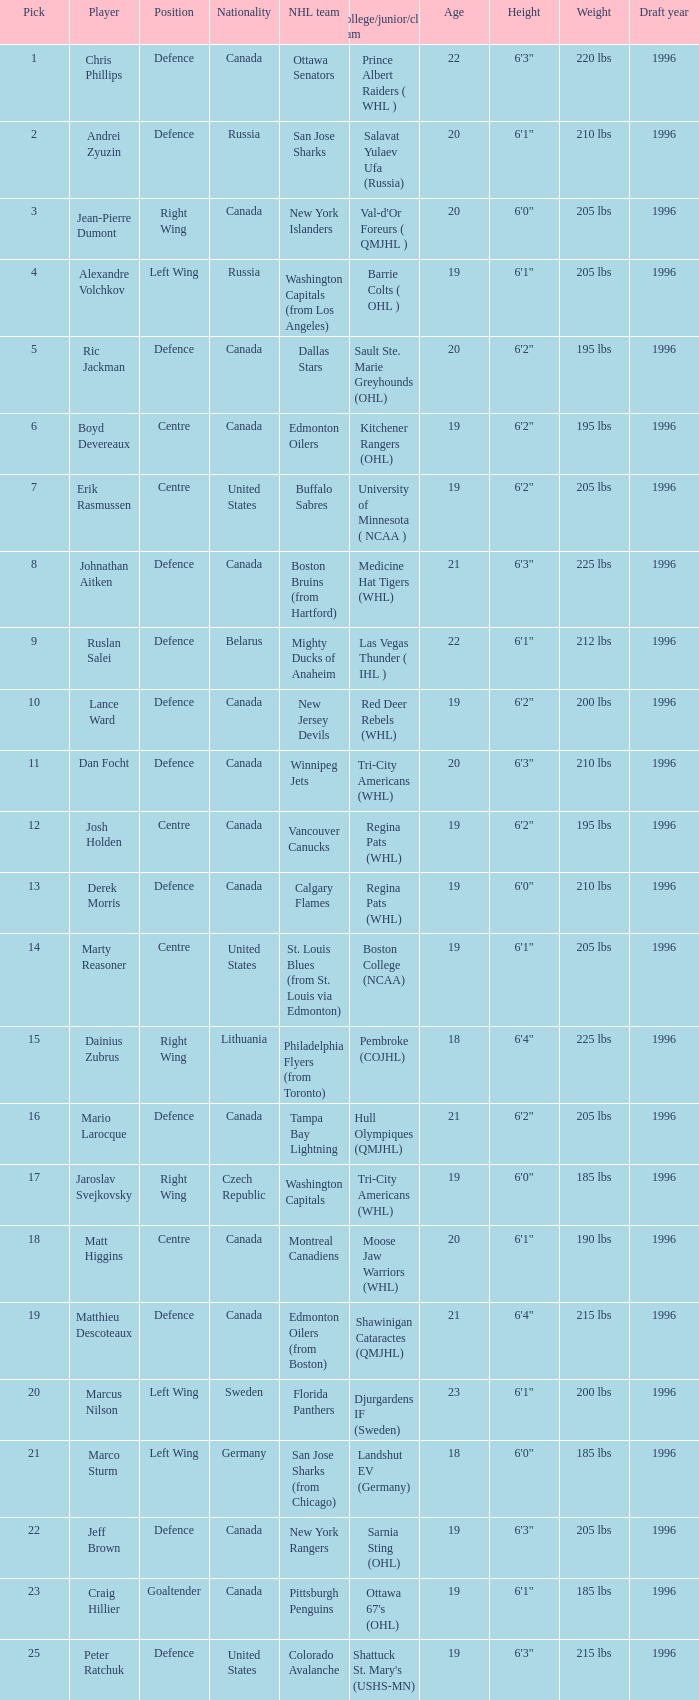What draft pick number was Ric Jackman? 5.0. 